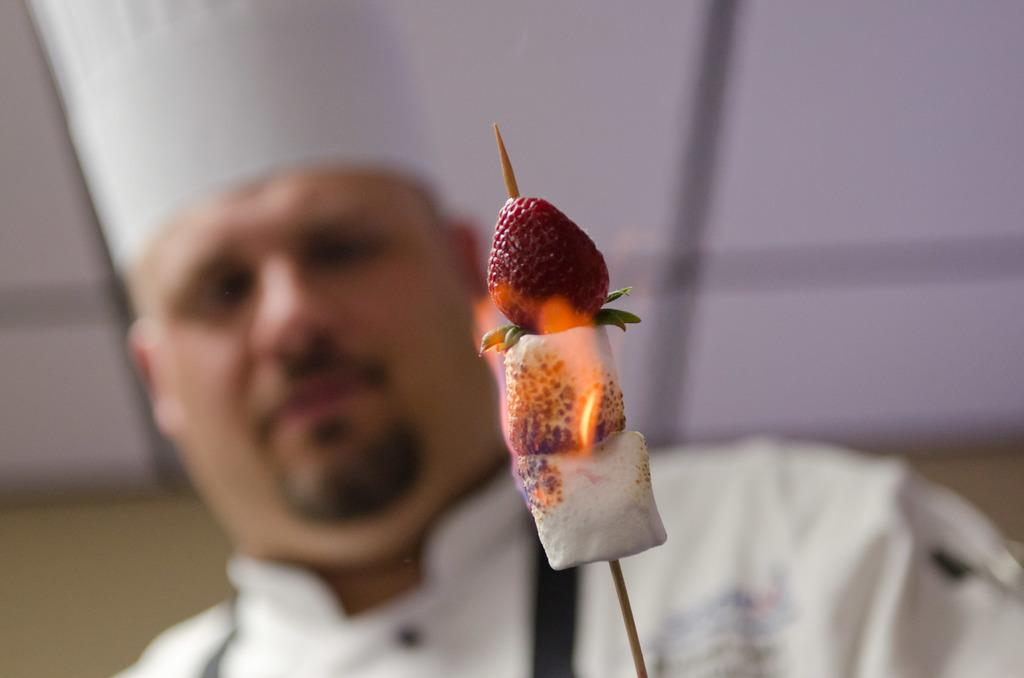What is the main object in the foreground of the image? There is a stick of strawberry in the foreground of the image. Can you describe the background of the image? There is a man in the background of the image. What type of sweater is the pig wearing in the image? There are no pigs or sweaters present in the image. 